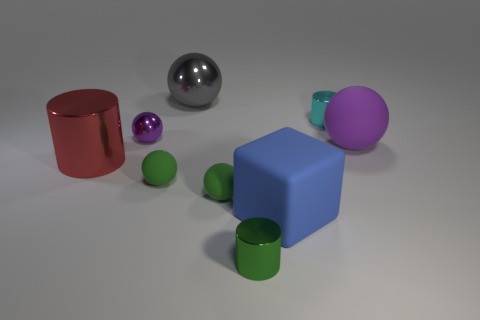Is there a blue cube made of the same material as the big red cylinder? Upon examining the image, we can determine that there is indeed a blue cube present. As for the material, both the cube and the red cylinder showcase similar reflective properties indicative of a polished surface. Although visual assessment doesn't allow for an absolute confirmation of the material composition, their appearances suggest that they could be made from the same or at least a visually similar material. 